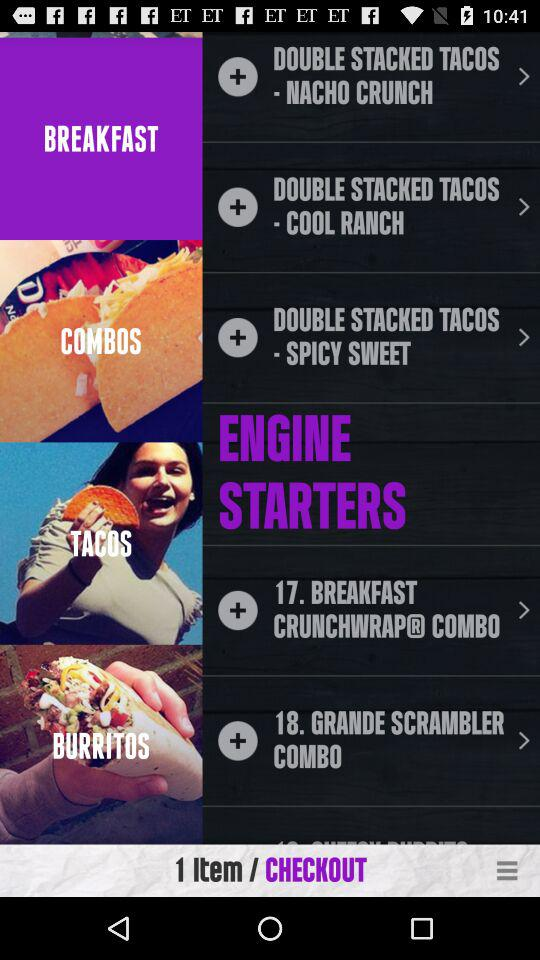How many items were added for checkout? The number of items added for checkout was 1. 